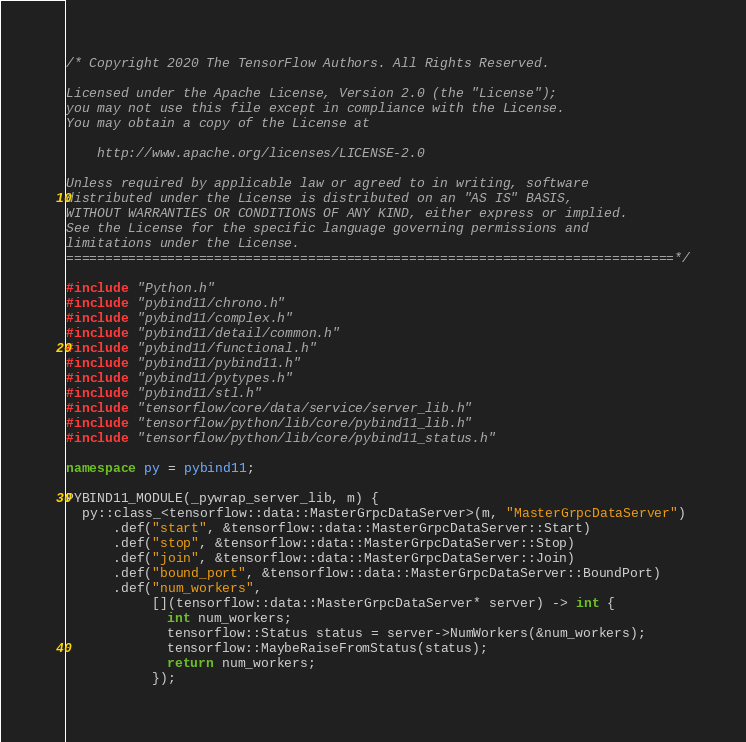Convert code to text. <code><loc_0><loc_0><loc_500><loc_500><_C++_>/* Copyright 2020 The TensorFlow Authors. All Rights Reserved.

Licensed under the Apache License, Version 2.0 (the "License");
you may not use this file except in compliance with the License.
You may obtain a copy of the License at

    http://www.apache.org/licenses/LICENSE-2.0

Unless required by applicable law or agreed to in writing, software
distributed under the License is distributed on an "AS IS" BASIS,
WITHOUT WARRANTIES OR CONDITIONS OF ANY KIND, either express or implied.
See the License for the specific language governing permissions and
limitations under the License.
==============================================================================*/

#include "Python.h"
#include "pybind11/chrono.h"
#include "pybind11/complex.h"
#include "pybind11/detail/common.h"
#include "pybind11/functional.h"
#include "pybind11/pybind11.h"
#include "pybind11/pytypes.h"
#include "pybind11/stl.h"
#include "tensorflow/core/data/service/server_lib.h"
#include "tensorflow/python/lib/core/pybind11_lib.h"
#include "tensorflow/python/lib/core/pybind11_status.h"

namespace py = pybind11;

PYBIND11_MODULE(_pywrap_server_lib, m) {
  py::class_<tensorflow::data::MasterGrpcDataServer>(m, "MasterGrpcDataServer")
      .def("start", &tensorflow::data::MasterGrpcDataServer::Start)
      .def("stop", &tensorflow::data::MasterGrpcDataServer::Stop)
      .def("join", &tensorflow::data::MasterGrpcDataServer::Join)
      .def("bound_port", &tensorflow::data::MasterGrpcDataServer::BoundPort)
      .def("num_workers",
           [](tensorflow::data::MasterGrpcDataServer* server) -> int {
             int num_workers;
             tensorflow::Status status = server->NumWorkers(&num_workers);
             tensorflow::MaybeRaiseFromStatus(status);
             return num_workers;
           });
</code> 